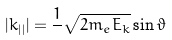<formula> <loc_0><loc_0><loc_500><loc_500>| k _ { | | } | = { \frac { 1 } { } } { \sqrt { 2 m _ { e } E _ { k } } } \sin \vartheta</formula> 